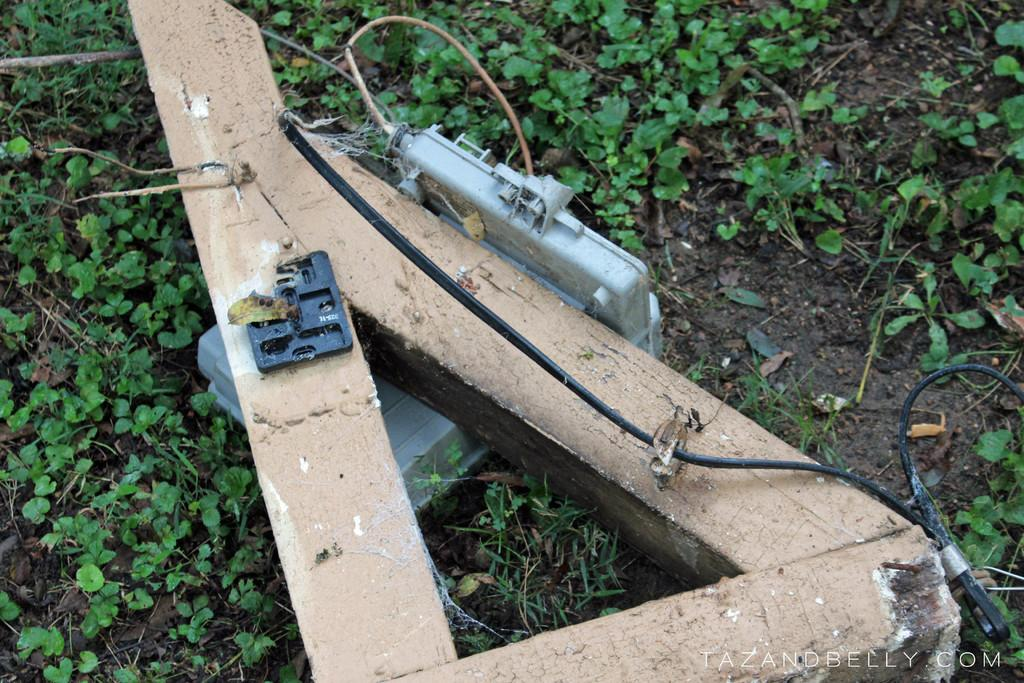What is the main object in the image? There is a wooden pole with cable in the image. Are there any other objects or features visible in the image? Yes, there are other things visible in the image. Can you describe the watermark on the image? Unfortunately, the watermark cannot be described as it is not visible in the image itself. What type of advice does the grandfather give to the ray in the image? There is no grandfather or ray present in the image, so it is not possible to answer that question. 